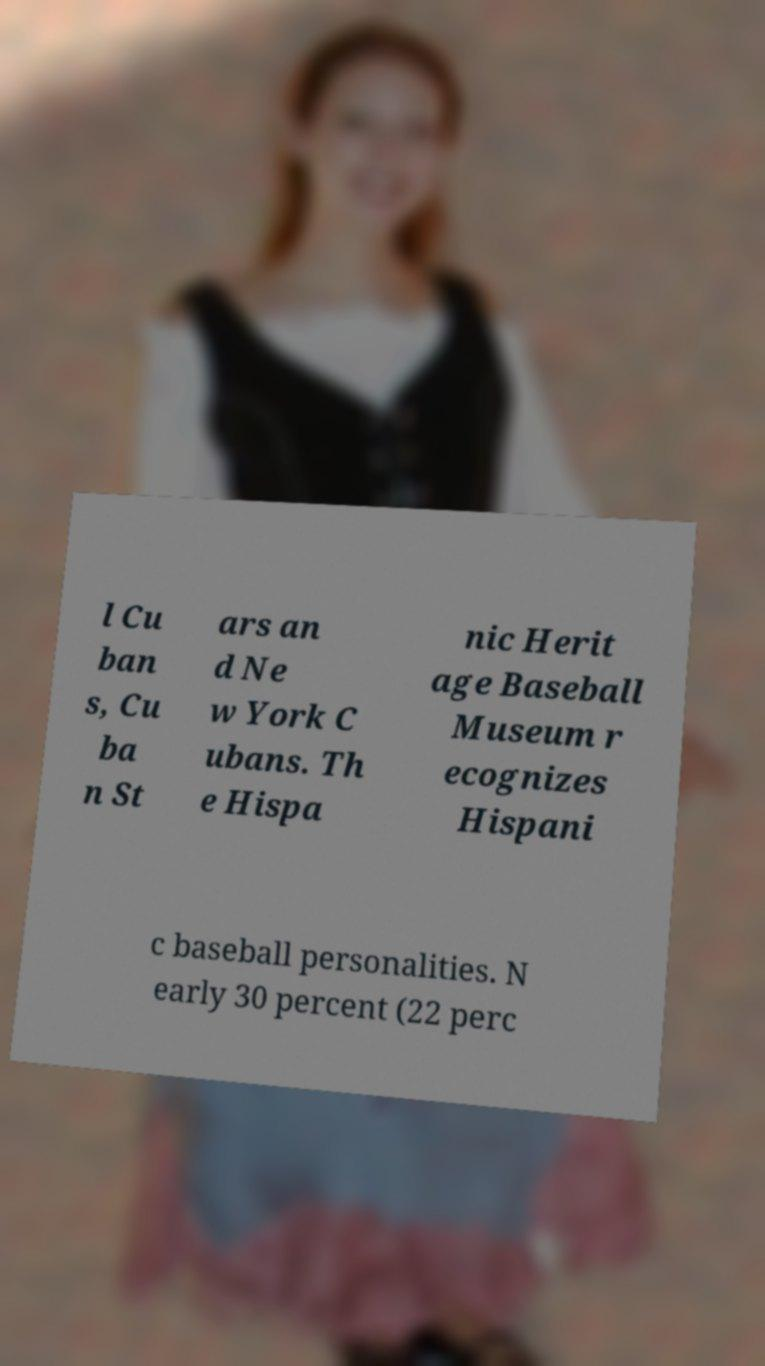What messages or text are displayed in this image? I need them in a readable, typed format. l Cu ban s, Cu ba n St ars an d Ne w York C ubans. Th e Hispa nic Herit age Baseball Museum r ecognizes Hispani c baseball personalities. N early 30 percent (22 perc 